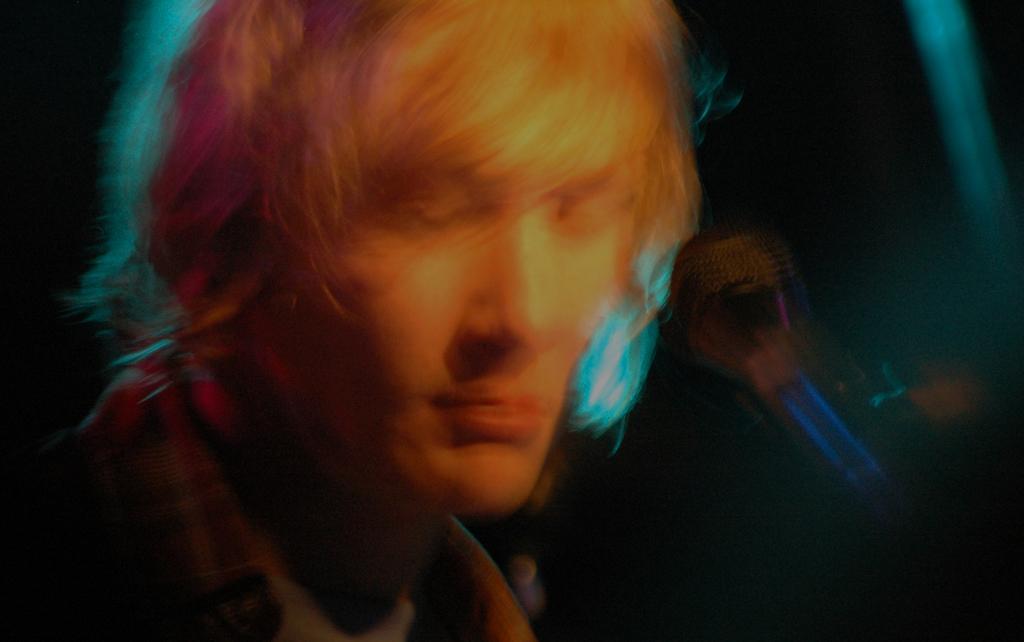In one or two sentences, can you explain what this image depicts? It is the blur image of a man. In front of him there is a mic. There are different colours to his hair. 